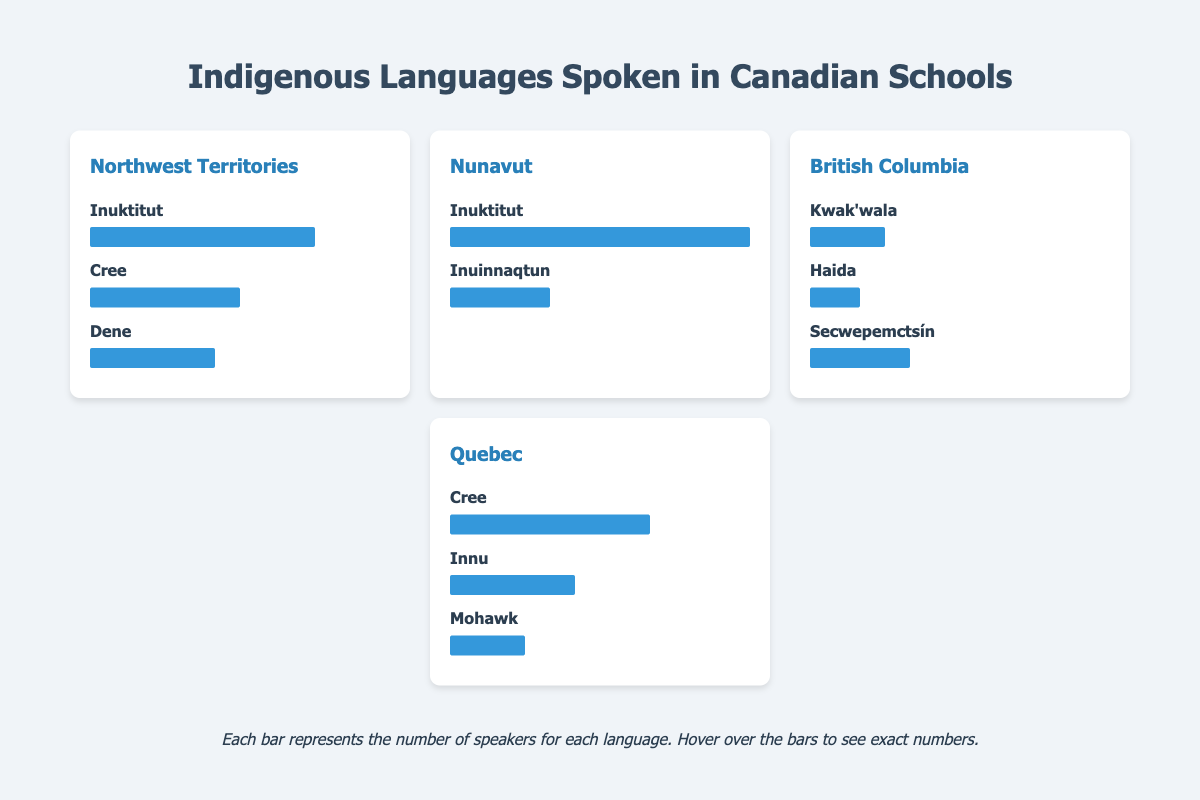Which region has the highest number of Inuktitut speakers? The region with the highest number of Inuktitut speakers is Nunavut, as indicated by the length of the corresponding bar which shows 800 speakers.
Answer: Nunavut How many indigenous languages are spoken in Quebec? In Quebec, there are three indigenous languages listed: Cree, Innu, and Mohawk.
Answer: 3 Compare the number of Cree speakers in Northwest Territories and Quebec. Which region has more? In Northwest Territories, there are 300 Cree speakers, whereas in Quebec, there are 400 Cree speakers. Therefore, Quebec has more Cree speakers.
Answer: Quebec What is the total number of speakers of all indigenous languages in British Columbia? Adding the speakers for Kwak'wala (150), Haida (100), and Secwepemctsín (200) gives a total of 450 speakers in British Columbia.
Answer: 450 Which language has the most speakers in Northwest Territories? The language with the most speakers in Northwest Territories is Inuktitut with 450 speakers.
Answer: Inuktitut What is the difference in the number of Inuktitut speakers between Nunavut and Northwest Territories? The number of Inuktitut speakers in Nunavut is 800, and in Northwest Territories, it is 450. The difference is 800 - 450 = 350.
Answer: 350 Identify the regions where Cree is spoken and count the total number of Cree speakers in those regions. Cree is spoken in Northwest Territories (300 speakers) and Quebec (400 speakers). The total number of Cree speakers in these regions is 300 + 400 = 700.
Answer: 700 How many more speakers does Inuinnaqtun have compared to Mohawk in their respective regions? Inuinnaqtun has 200 speakers in Nunavut, whereas Mohawk has 150 speakers in Quebec. The difference is 200 - 150 = 50.
Answer: 50 Based on the data, which language has the least number of speakers in British Columbia? Haida has the least number of speakers in British Columbia with 100 speakers.
Answer: Haida 